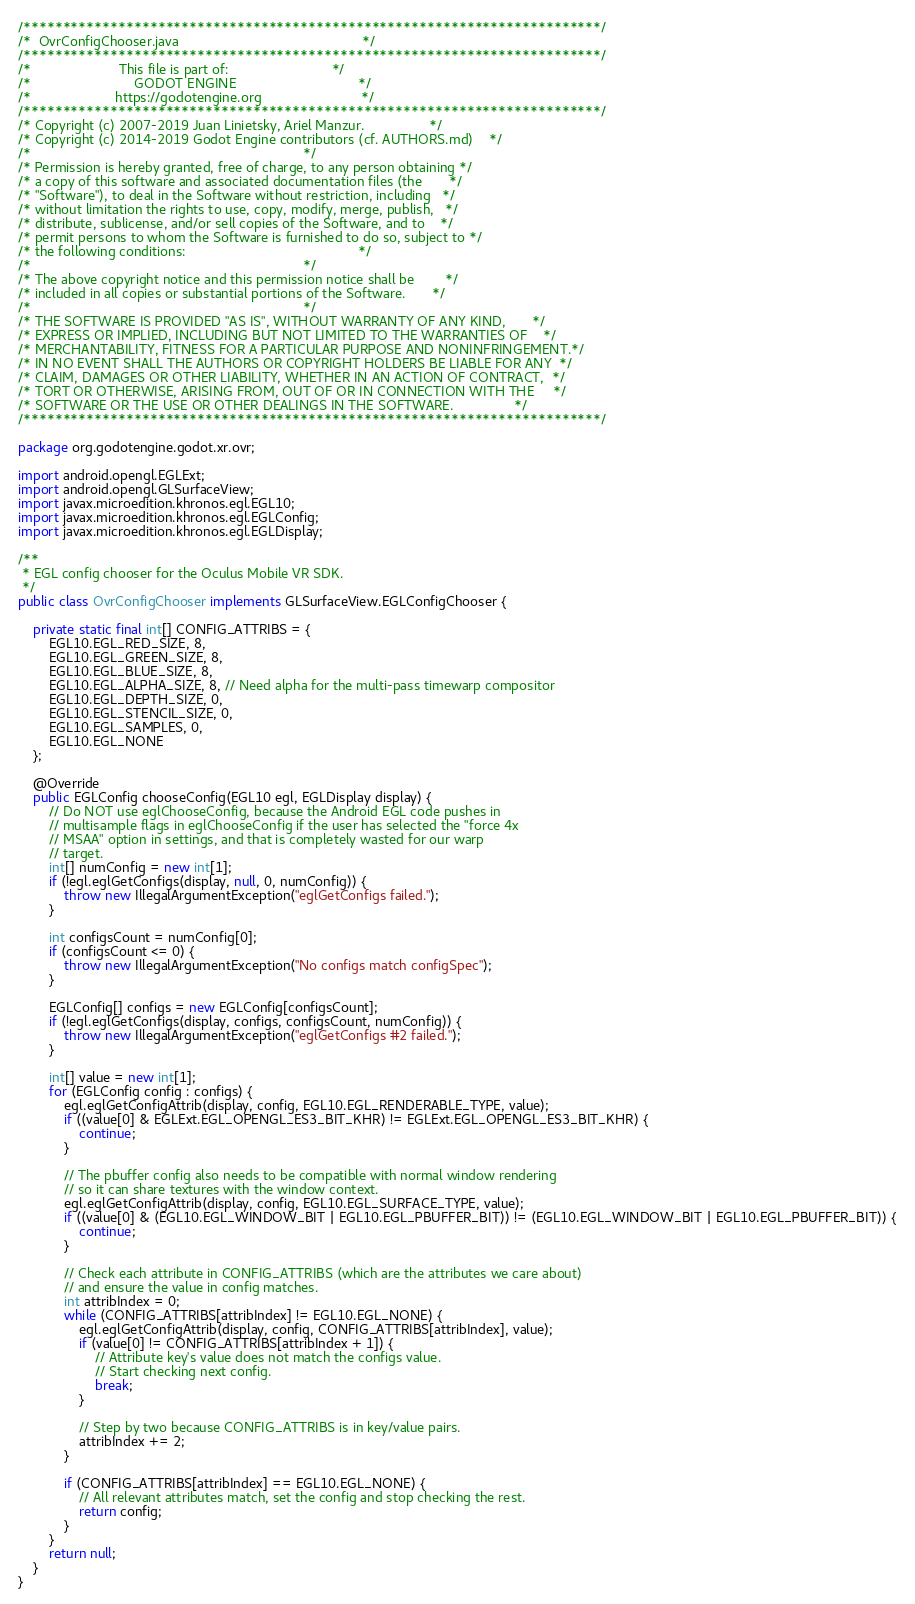Convert code to text. <code><loc_0><loc_0><loc_500><loc_500><_Java_>/*************************************************************************/
/*  OvrConfigChooser.java                                                */
/*************************************************************************/
/*                       This file is part of:                           */
/*                           GODOT ENGINE                                */
/*                      https://godotengine.org                          */
/*************************************************************************/
/* Copyright (c) 2007-2019 Juan Linietsky, Ariel Manzur.                 */
/* Copyright (c) 2014-2019 Godot Engine contributors (cf. AUTHORS.md)    */
/*                                                                       */
/* Permission is hereby granted, free of charge, to any person obtaining */
/* a copy of this software and associated documentation files (the       */
/* "Software"), to deal in the Software without restriction, including   */
/* without limitation the rights to use, copy, modify, merge, publish,   */
/* distribute, sublicense, and/or sell copies of the Software, and to    */
/* permit persons to whom the Software is furnished to do so, subject to */
/* the following conditions:                                             */
/*                                                                       */
/* The above copyright notice and this permission notice shall be        */
/* included in all copies or substantial portions of the Software.       */
/*                                                                       */
/* THE SOFTWARE IS PROVIDED "AS IS", WITHOUT WARRANTY OF ANY KIND,       */
/* EXPRESS OR IMPLIED, INCLUDING BUT NOT LIMITED TO THE WARRANTIES OF    */
/* MERCHANTABILITY, FITNESS FOR A PARTICULAR PURPOSE AND NONINFRINGEMENT.*/
/* IN NO EVENT SHALL THE AUTHORS OR COPYRIGHT HOLDERS BE LIABLE FOR ANY  */
/* CLAIM, DAMAGES OR OTHER LIABILITY, WHETHER IN AN ACTION OF CONTRACT,  */
/* TORT OR OTHERWISE, ARISING FROM, OUT OF OR IN CONNECTION WITH THE     */
/* SOFTWARE OR THE USE OR OTHER DEALINGS IN THE SOFTWARE.                */
/*************************************************************************/

package org.godotengine.godot.xr.ovr;

import android.opengl.EGLExt;
import android.opengl.GLSurfaceView;
import javax.microedition.khronos.egl.EGL10;
import javax.microedition.khronos.egl.EGLConfig;
import javax.microedition.khronos.egl.EGLDisplay;

/**
 * EGL config chooser for the Oculus Mobile VR SDK.
 */
public class OvrConfigChooser implements GLSurfaceView.EGLConfigChooser {

	private static final int[] CONFIG_ATTRIBS = {
		EGL10.EGL_RED_SIZE, 8,
		EGL10.EGL_GREEN_SIZE, 8,
		EGL10.EGL_BLUE_SIZE, 8,
		EGL10.EGL_ALPHA_SIZE, 8, // Need alpha for the multi-pass timewarp compositor
		EGL10.EGL_DEPTH_SIZE, 0,
		EGL10.EGL_STENCIL_SIZE, 0,
		EGL10.EGL_SAMPLES, 0,
		EGL10.EGL_NONE
	};

	@Override
	public EGLConfig chooseConfig(EGL10 egl, EGLDisplay display) {
		// Do NOT use eglChooseConfig, because the Android EGL code pushes in
		// multisample flags in eglChooseConfig if the user has selected the "force 4x
		// MSAA" option in settings, and that is completely wasted for our warp
		// target.
		int[] numConfig = new int[1];
		if (!egl.eglGetConfigs(display, null, 0, numConfig)) {
			throw new IllegalArgumentException("eglGetConfigs failed.");
		}

		int configsCount = numConfig[0];
		if (configsCount <= 0) {
			throw new IllegalArgumentException("No configs match configSpec");
		}

		EGLConfig[] configs = new EGLConfig[configsCount];
		if (!egl.eglGetConfigs(display, configs, configsCount, numConfig)) {
			throw new IllegalArgumentException("eglGetConfigs #2 failed.");
		}

		int[] value = new int[1];
		for (EGLConfig config : configs) {
			egl.eglGetConfigAttrib(display, config, EGL10.EGL_RENDERABLE_TYPE, value);
			if ((value[0] & EGLExt.EGL_OPENGL_ES3_BIT_KHR) != EGLExt.EGL_OPENGL_ES3_BIT_KHR) {
				continue;
			}

			// The pbuffer config also needs to be compatible with normal window rendering
			// so it can share textures with the window context.
			egl.eglGetConfigAttrib(display, config, EGL10.EGL_SURFACE_TYPE, value);
			if ((value[0] & (EGL10.EGL_WINDOW_BIT | EGL10.EGL_PBUFFER_BIT)) != (EGL10.EGL_WINDOW_BIT | EGL10.EGL_PBUFFER_BIT)) {
				continue;
			}

			// Check each attribute in CONFIG_ATTRIBS (which are the attributes we care about)
			// and ensure the value in config matches.
			int attribIndex = 0;
			while (CONFIG_ATTRIBS[attribIndex] != EGL10.EGL_NONE) {
				egl.eglGetConfigAttrib(display, config, CONFIG_ATTRIBS[attribIndex], value);
				if (value[0] != CONFIG_ATTRIBS[attribIndex + 1]) {
					// Attribute key's value does not match the configs value.
					// Start checking next config.
					break;
				}

				// Step by two because CONFIG_ATTRIBS is in key/value pairs.
				attribIndex += 2;
			}

			if (CONFIG_ATTRIBS[attribIndex] == EGL10.EGL_NONE) {
				// All relevant attributes match, set the config and stop checking the rest.
				return config;
			}
		}
		return null;
	}
}
</code> 